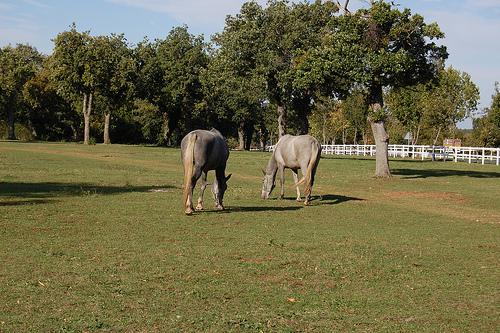Question: what color is the fence in the background?
Choices:
A. Black.
B. Brown.
C. Yellow.
D. White.
Answer with the letter. Answer: D Question: why are the horses bent down?
Choices:
A. They are drinking.
B. They are sleeping.
C. They are eating.
D. They are playing.
Answer with the letter. Answer: C Question: what color are the horses?
Choices:
A. Black.
B. Brown.
C. White.
D. Gray.
Answer with the letter. Answer: D Question: what are the animals pictured?
Choices:
A. Llama.
B. Cow.
C. Camel.
D. Horses.
Answer with the letter. Answer: D Question: where was this located?
Choices:
A. On a ranch.
B. In a field.
C. In a forest.
D. On a farm.
Answer with the letter. Answer: D 